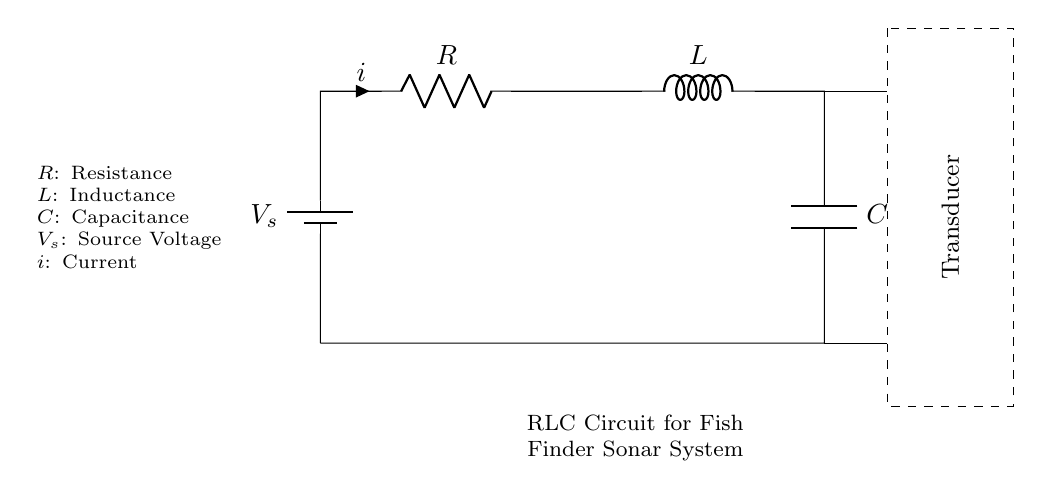What type of circuit is illustrated? The circuit is an RLC circuit, characterized by the presence of a resistor, inductor, and capacitor in series connected to a voltage source.
Answer: RLC circuit What is the function of the component labeled R? R stands for resistance, which opposes the flow of current in the circuit. This helps in controlling the current and voltage levels within the circuit.
Answer: Resistance What is the role of the inductor (L) in this circuit? The inductor stores energy in a magnetic field when current flows through it and also helps to manage changes in current, making it essential for filtering and signal processing in the sonar system.
Answer: Energy storage What does the voltage source (V_s) provide? The voltage source supplies electrical energy to the entire circuit, creating a potential difference that drives the current through the circuit components.
Answer: Electrical energy Describe the purpose of the transducer in the sonar system. The transducer converts electrical energy from the RLC circuit into sound waves, which travel through water and reflect off objects, enabling detection and location of fish or underwater terrain.
Answer: Sound wave conversion How does the capacitor (C) affect the circuit's behavior? The capacitor stores and releases electrical energy; it helps in filtering and stabilizing voltage within the circuit, affecting the frequency response and overall performance of the sonar system.
Answer: Voltage stabilization What is the effect of increasing the inductance (L) in this circuit? Increasing the inductance enhances the ability to store energy in the magnetic field, which results in a slower response to changes in current and can alter the resonant frequency, potentially making the sonar system more sensitive to specific frequencies.
Answer: Slower response 